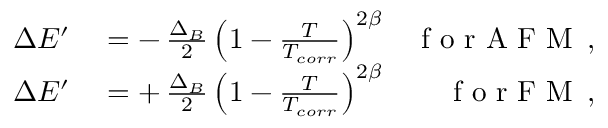Convert formula to latex. <formula><loc_0><loc_0><loc_500><loc_500>\begin{array} { r l r } { \Delta E ^ { \prime } } & = - \, \frac { \Delta _ { B } } { 2 } \left ( 1 - \frac { T } { T _ { c o r r } } \right ) ^ { 2 \beta } } & { f o r A F M \, , } \\ { \Delta E ^ { \prime } } & = + \, \frac { \Delta _ { B } } { 2 } \left ( 1 - \frac { T } { T _ { c o r r } } \right ) ^ { 2 \beta } } & { f o r F M \, , } \end{array}</formula> 